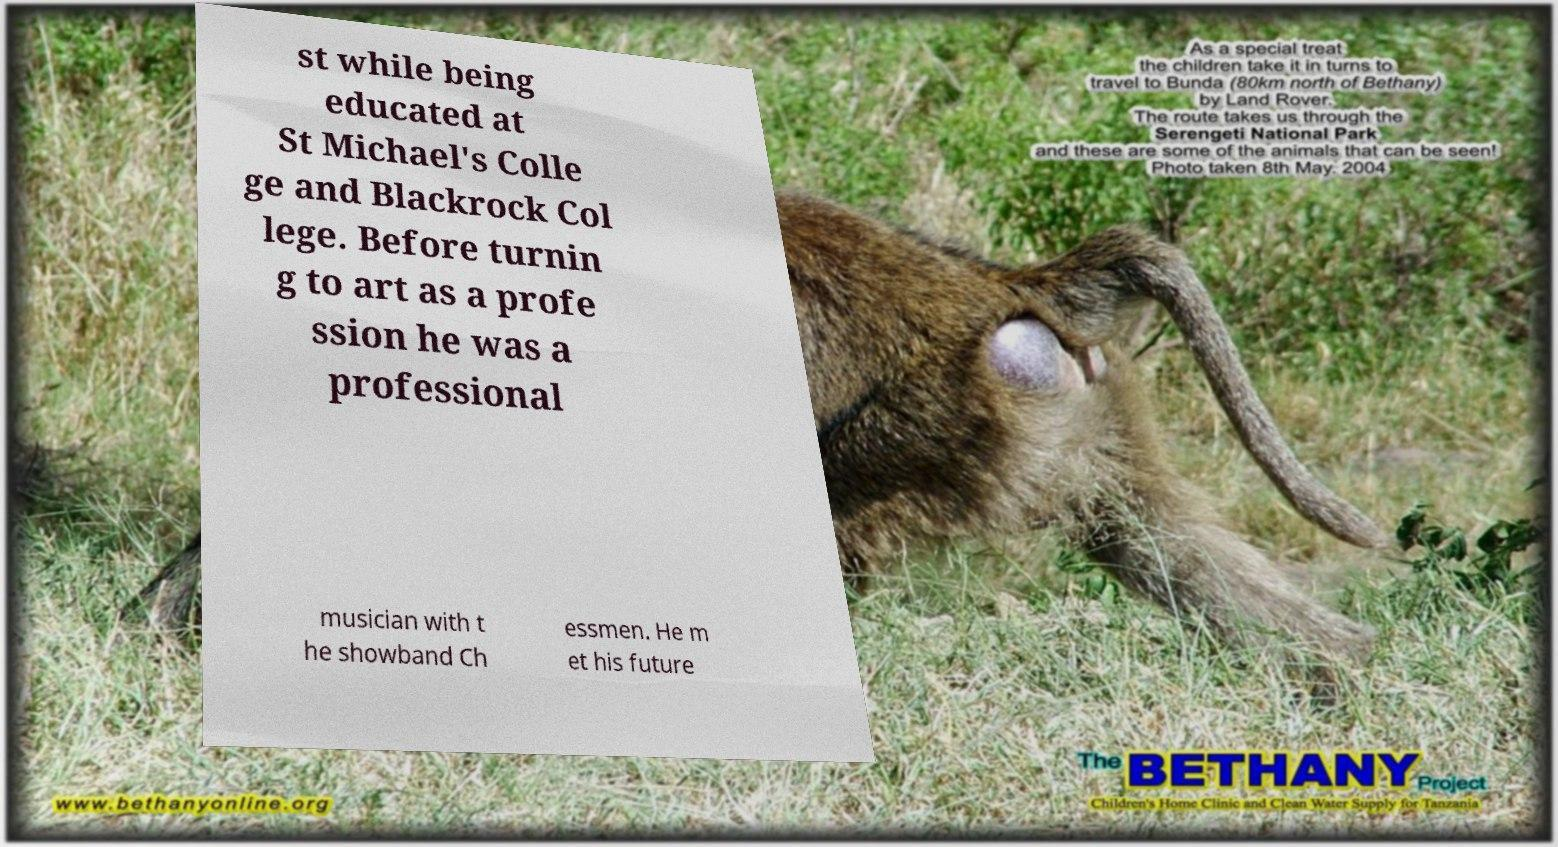For documentation purposes, I need the text within this image transcribed. Could you provide that? st while being educated at St Michael's Colle ge and Blackrock Col lege. Before turnin g to art as a profe ssion he was a professional musician with t he showband Ch essmen. He m et his future 